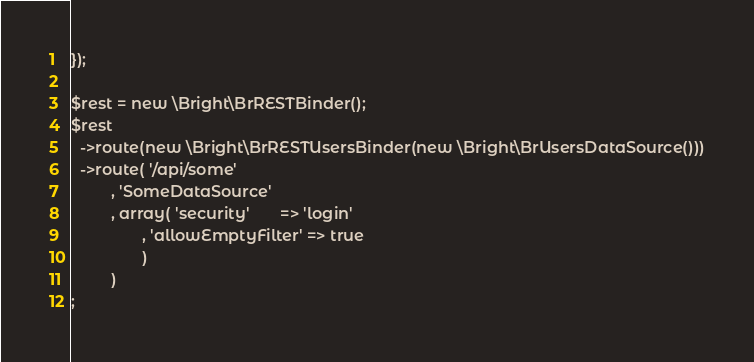Convert code to text. <code><loc_0><loc_0><loc_500><loc_500><_PHP_>
});

$rest = new \Bright\BrRESTBinder();
$rest
  ->route(new \Bright\BrRESTUsersBinder(new \Bright\BrUsersDataSource()))
  ->route( '/api/some'
         , 'SomeDataSource'
         , array( 'security'       => 'login'
                , 'allowEmptyFilter' => true
                )
         )
;
</code> 